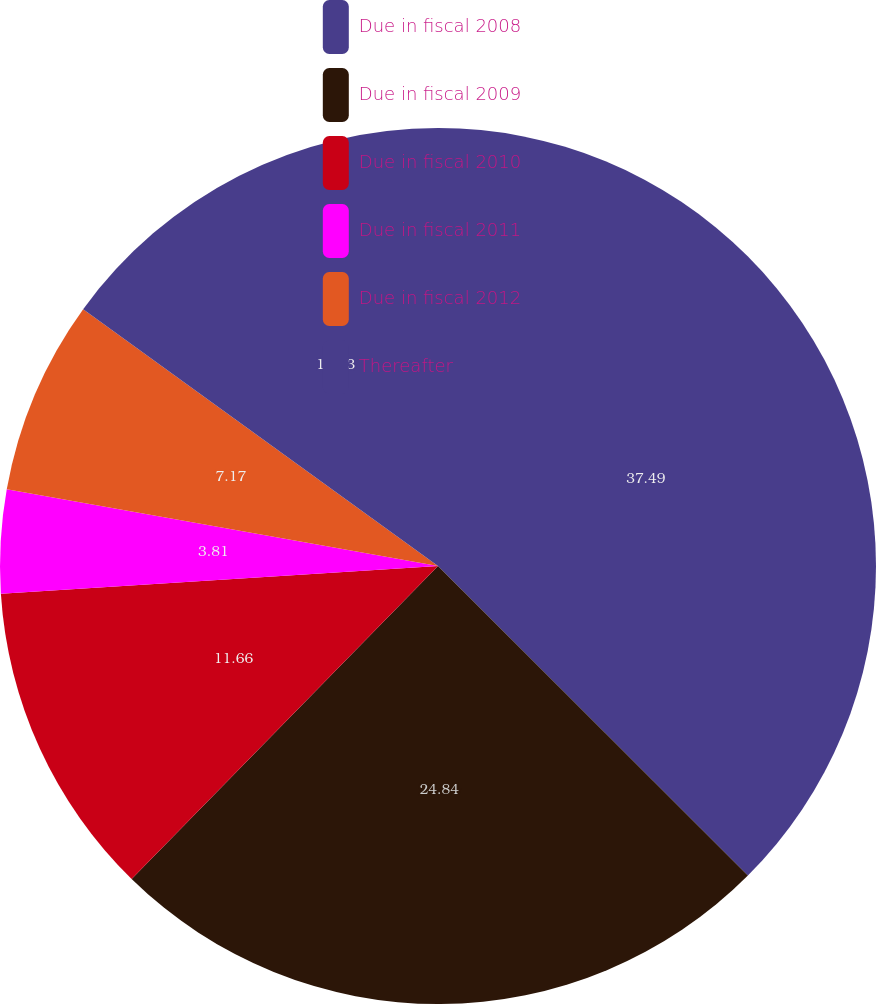Convert chart. <chart><loc_0><loc_0><loc_500><loc_500><pie_chart><fcel>Due in fiscal 2008<fcel>Due in fiscal 2009<fcel>Due in fiscal 2010<fcel>Due in fiscal 2011<fcel>Due in fiscal 2012<fcel>Thereafter<nl><fcel>37.49%<fcel>24.84%<fcel>11.66%<fcel>3.81%<fcel>7.17%<fcel>15.03%<nl></chart> 